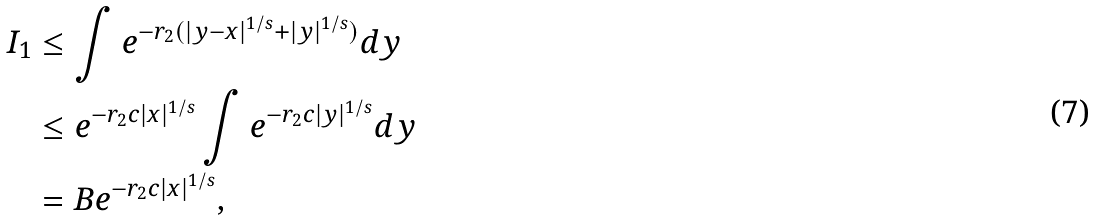<formula> <loc_0><loc_0><loc_500><loc_500>I _ { 1 } & \leq \int e ^ { - r _ { 2 } ( | y - x | ^ { 1 / s } + | y | ^ { 1 / s } ) } d y \\ & \leq e ^ { - r _ { 2 } c | x | ^ { 1 / s } } \int e ^ { - r _ { 2 } c | y | ^ { 1 / s } } d y \\ & = B e ^ { - r _ { 2 } c | x | ^ { 1 / s } } ,</formula> 